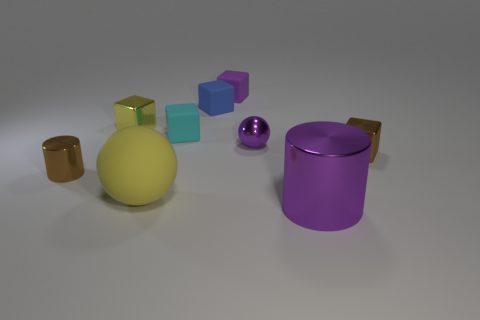What is the size of the shiny cylinder that is the same color as the small metal sphere?
Keep it short and to the point. Large. Are there an equal number of large matte things that are right of the small purple matte thing and tiny brown cubes that are behind the large metal cylinder?
Your answer should be very brief. No. How many other things are the same size as the purple cylinder?
Your response must be concise. 1. What size is the purple shiny sphere?
Provide a short and direct response. Small. Are the purple block and the sphere to the right of the cyan cube made of the same material?
Ensure brevity in your answer.  No. Are there any small purple matte things that have the same shape as the blue object?
Keep it short and to the point. Yes. There is a thing that is the same size as the yellow sphere; what is its material?
Keep it short and to the point. Metal. There is a rubber cube that is to the left of the blue matte block; what size is it?
Offer a very short reply. Small. There is a blue rubber thing behind the tiny cyan cube; does it have the same size as the yellow rubber sphere that is to the left of the big purple shiny object?
Your answer should be compact. No. What number of tiny purple things have the same material as the tiny brown cube?
Make the answer very short. 1. 